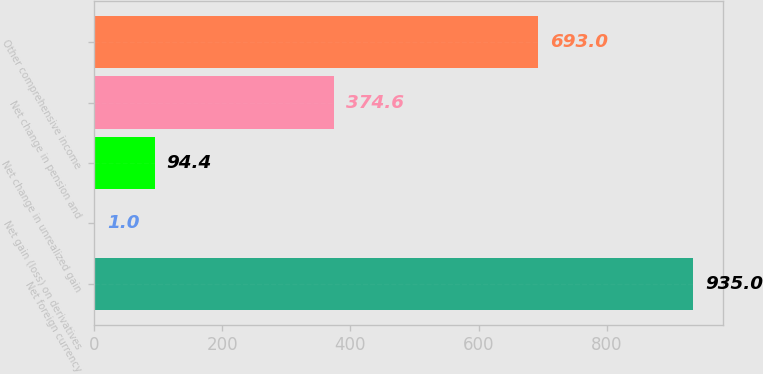<chart> <loc_0><loc_0><loc_500><loc_500><bar_chart><fcel>Net foreign currency<fcel>Net gain (loss) on derivatives<fcel>Net change in unrealized gain<fcel>Net change in pension and<fcel>Other comprehensive income<nl><fcel>935<fcel>1<fcel>94.4<fcel>374.6<fcel>693<nl></chart> 